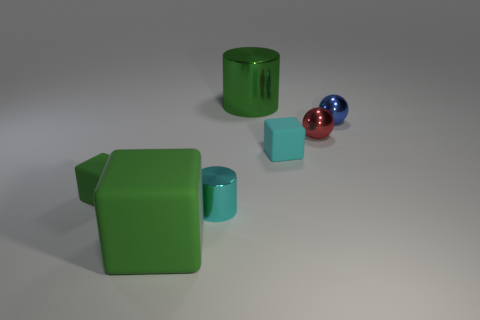How many shiny things are tiny blue balls or tiny red things?
Offer a terse response. 2. There is a shiny object that is both behind the small red metallic sphere and to the right of the small cyan cube; what is its color?
Give a very brief answer. Blue. There is a blue shiny ball; how many small red shiny balls are in front of it?
Provide a succinct answer. 1. What is the blue ball made of?
Provide a succinct answer. Metal. What color is the big object that is on the right side of the green rubber cube that is right of the tiny block that is to the left of the large green shiny cylinder?
Offer a very short reply. Green. How many red metallic balls have the same size as the blue sphere?
Provide a short and direct response. 1. What is the color of the tiny shiny thing that is in front of the cyan rubber block?
Provide a short and direct response. Cyan. What number of other things are there of the same size as the green cylinder?
Ensure brevity in your answer.  1. There is a matte block that is both on the right side of the tiny green block and left of the large green metal thing; what is its size?
Your answer should be very brief. Large. There is a big metallic thing; does it have the same color as the small object on the left side of the large green block?
Offer a very short reply. Yes. 